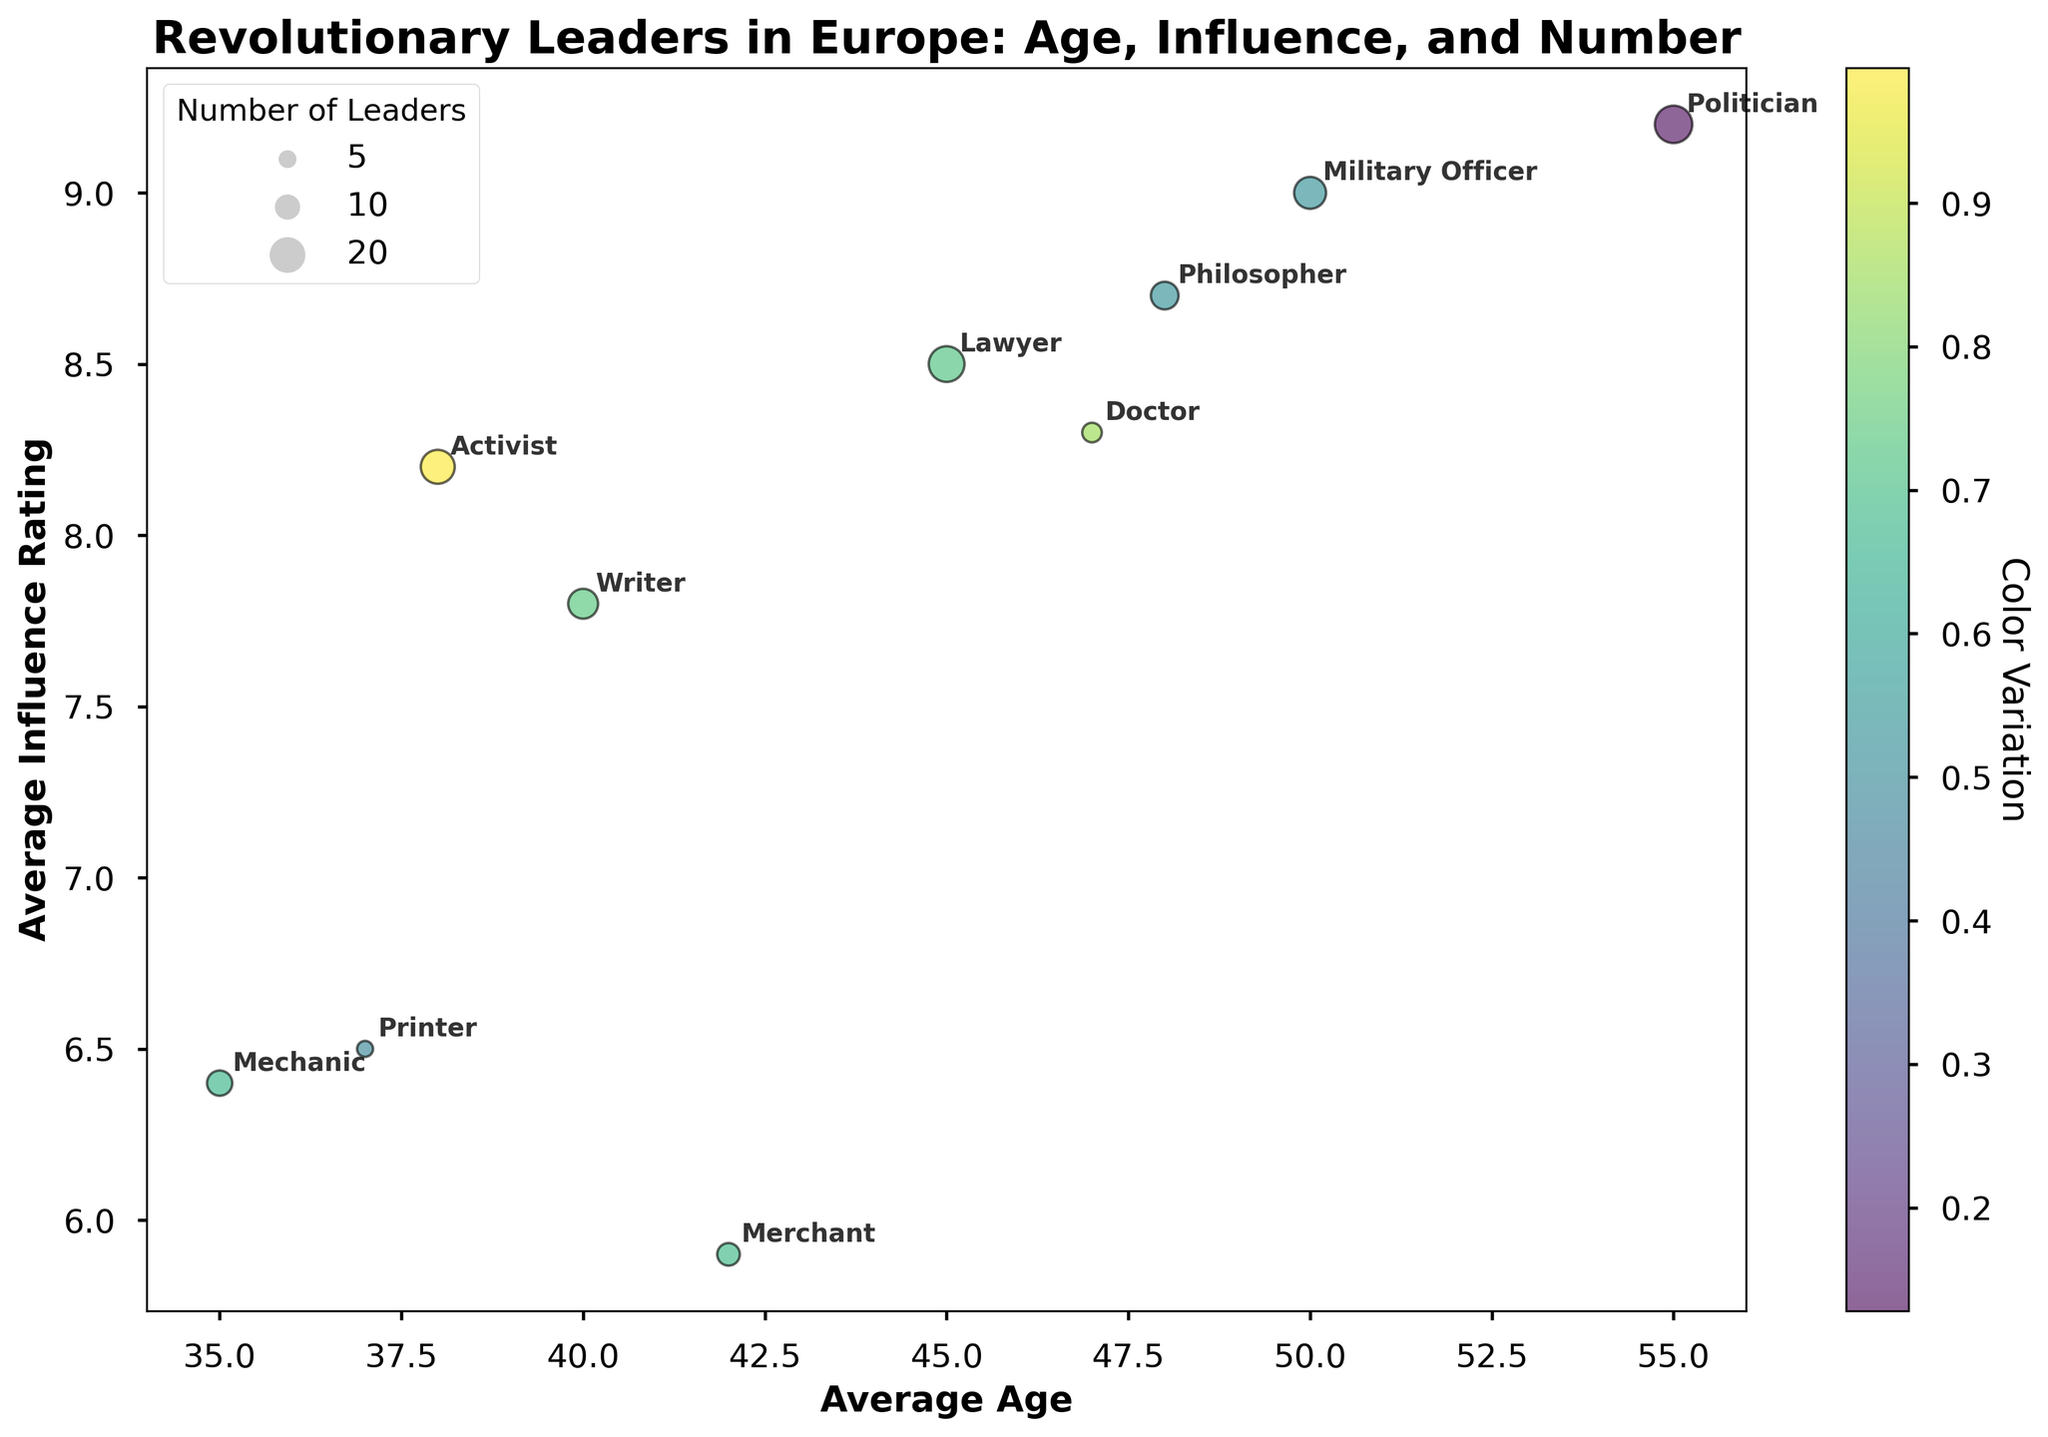What's the title of the figure? The title of the figure is found at the top and provides a summary of the data being visualized. In this case, the title is "Revolutionary Leaders in Europe: Age, Influence, and Number."
Answer: Revolutionary Leaders in Europe: Age, Influence, and Number What's the xlabel of the figure? The xlabel is located along the horizontal axis of the plot and denotes what the x-axis represents. Here, it specifies "Average Age."
Answer: Average Age Which occupation has the highest Average Influence Rating? By examining the y-axis, you can see that the "Politician" bubble is positioned at the highest point on the y-axis with a Average Influence Rating of 9.2.
Answer: Politician How many leaders are from the "University, Philosopher" background? This type of question can be answered by looking at the bubble sizes. The size of the bubble is scaled to reflect the number of leaders. The bubble labeled "Philosopher" has a size indicating 6 leaders.
Answer: 6 Which background has both the smallest number of leaders and their average influence rating? The "Self-taught, Printer" bubble is the smallest, representing 2 leaders. It is situated at the y-axis value of 6.5, indicating their average influence rating.
Answer: Self-taught, Printer What is the range of Average Ages among leaders from a University background? First, identify the bubbles associated with University backgrounds: Lawyer, Military Officer, Philosopher, Doctor, Politician. Their respective average ages are 45, 50, 48, 47, and 55. The range is calculated by subtracting the minimum age (45) from the maximum age (55).
Answer: 10 years If you compare activists and writers, which group has a higher influence rating on average? Identify the bubbles labeled "Activist" and "Writer." The "Activist" bubble is positioned at a y-axis value of 8.2, while the "Writer" bubble is at 7.8. Thus, activists have a higher average influence rating.
Answer: Activists Are there more leaders who are Self-taught or University-educated, based on the total number of leaders? Sum the number of leaders in each group: University-educated includes Lawyer (10), Military Officer (8), Philosopher (6), Doctor (3), Politician (11), total of 38. Self-taught includes Writer (7), Activist (9), Printer (2), total of 18. Therefore, there are more University-educated leaders.
Answer: University-educated What is the relationship between Average Influence Rating and Number of Leaders for Revolutionaries who were Military Officers? The "Military Officer" bubble, representing 8 leaders with an average influence rating of 9.0, suggests a positive correlation between high influence ratings and a substantial number of leaders.
Answer: Positive correlation Which occupation has the youngest average age and what is it? By referring to the x-axis, the "Mechanic" bubble is at the far left, indicating the lowest average age of 35.
Answer: Mechanic, 35 